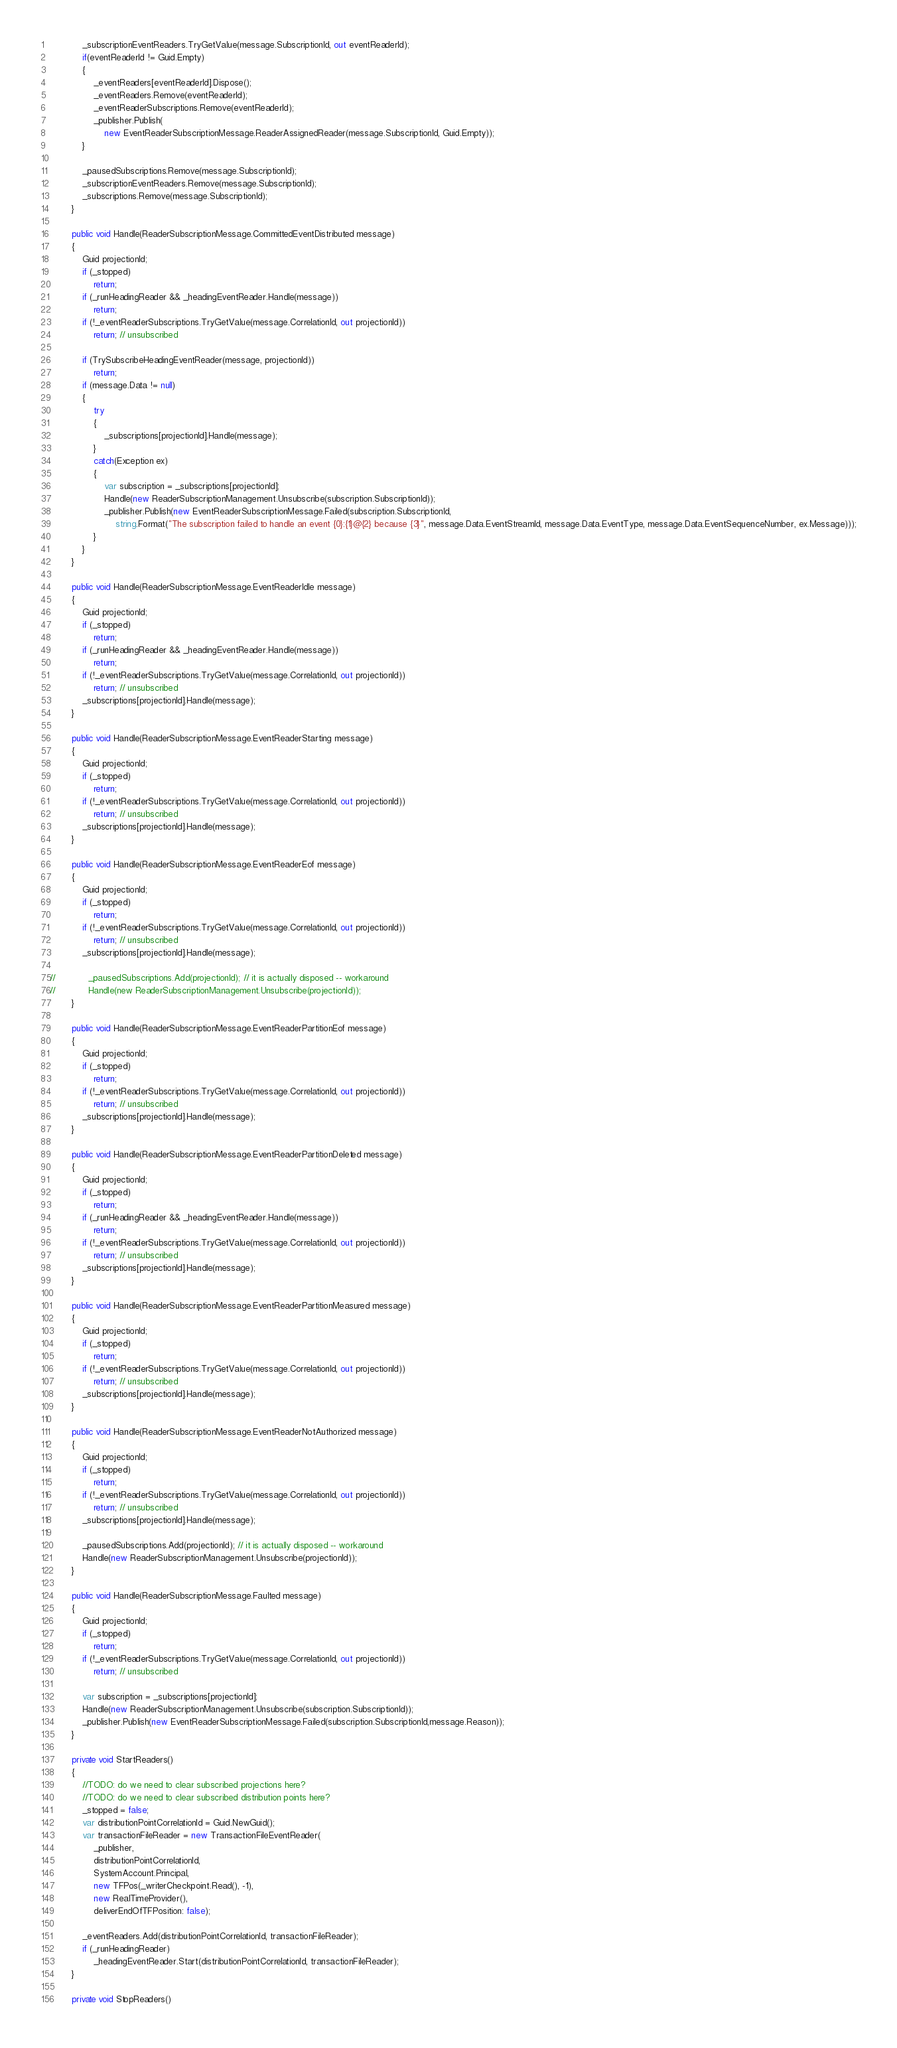Convert code to text. <code><loc_0><loc_0><loc_500><loc_500><_C#_>            _subscriptionEventReaders.TryGetValue(message.SubscriptionId, out eventReaderId);
            if(eventReaderId != Guid.Empty)
            {
                _eventReaders[eventReaderId].Dispose();
                _eventReaders.Remove(eventReaderId);
                _eventReaderSubscriptions.Remove(eventReaderId);
                _publisher.Publish(
                    new EventReaderSubscriptionMessage.ReaderAssignedReader(message.SubscriptionId, Guid.Empty));
            }

            _pausedSubscriptions.Remove(message.SubscriptionId);
            _subscriptionEventReaders.Remove(message.SubscriptionId);
            _subscriptions.Remove(message.SubscriptionId);
        }

        public void Handle(ReaderSubscriptionMessage.CommittedEventDistributed message)
        {
            Guid projectionId;
            if (_stopped)
                return;
            if (_runHeadingReader && _headingEventReader.Handle(message))
                return;
            if (!_eventReaderSubscriptions.TryGetValue(message.CorrelationId, out projectionId))
                return; // unsubscribed

            if (TrySubscribeHeadingEventReader(message, projectionId))
                return;
            if (message.Data != null)
            {
                try
                {
                    _subscriptions[projectionId].Handle(message);
                }
                catch(Exception ex)
                {
                    var subscription = _subscriptions[projectionId];
                    Handle(new ReaderSubscriptionManagement.Unsubscribe(subscription.SubscriptionId));
                    _publisher.Publish(new EventReaderSubscriptionMessage.Failed(subscription.SubscriptionId,
                        string.Format("The subscription failed to handle an event {0}:{1}@{2} because {3}", message.Data.EventStreamId, message.Data.EventType, message.Data.EventSequenceNumber, ex.Message)));
                }
            }
        }

        public void Handle(ReaderSubscriptionMessage.EventReaderIdle message)
        {
            Guid projectionId;
            if (_stopped)
                return;
            if (_runHeadingReader && _headingEventReader.Handle(message))
                return;
            if (!_eventReaderSubscriptions.TryGetValue(message.CorrelationId, out projectionId))
                return; // unsubscribed
            _subscriptions[projectionId].Handle(message);
        }

        public void Handle(ReaderSubscriptionMessage.EventReaderStarting message)
        {
            Guid projectionId;
            if (_stopped)
                return;
            if (!_eventReaderSubscriptions.TryGetValue(message.CorrelationId, out projectionId))
                return; // unsubscribed
            _subscriptions[projectionId].Handle(message);
        }

        public void Handle(ReaderSubscriptionMessage.EventReaderEof message)
        {
            Guid projectionId;
            if (_stopped)
                return;
            if (!_eventReaderSubscriptions.TryGetValue(message.CorrelationId, out projectionId))
                return; // unsubscribed
            _subscriptions[projectionId].Handle(message);

//            _pausedSubscriptions.Add(projectionId); // it is actually disposed -- workaround
//            Handle(new ReaderSubscriptionManagement.Unsubscribe(projectionId));
        }

        public void Handle(ReaderSubscriptionMessage.EventReaderPartitionEof message)
        {
            Guid projectionId;
            if (_stopped)
                return;
            if (!_eventReaderSubscriptions.TryGetValue(message.CorrelationId, out projectionId))
                return; // unsubscribed
            _subscriptions[projectionId].Handle(message);
        }

        public void Handle(ReaderSubscriptionMessage.EventReaderPartitionDeleted message)
        {
            Guid projectionId;
            if (_stopped)
                return;
            if (_runHeadingReader && _headingEventReader.Handle(message))
                return;
            if (!_eventReaderSubscriptions.TryGetValue(message.CorrelationId, out projectionId))
                return; // unsubscribed
            _subscriptions[projectionId].Handle(message);
        }

        public void Handle(ReaderSubscriptionMessage.EventReaderPartitionMeasured message)
        {
            Guid projectionId;
            if (_stopped)
                return;
            if (!_eventReaderSubscriptions.TryGetValue(message.CorrelationId, out projectionId))
                return; // unsubscribed
            _subscriptions[projectionId].Handle(message);
        }

        public void Handle(ReaderSubscriptionMessage.EventReaderNotAuthorized message)
        {
            Guid projectionId;
            if (_stopped)
                return;
            if (!_eventReaderSubscriptions.TryGetValue(message.CorrelationId, out projectionId))
                return; // unsubscribed
            _subscriptions[projectionId].Handle(message);

            _pausedSubscriptions.Add(projectionId); // it is actually disposed -- workaround
            Handle(new ReaderSubscriptionManagement.Unsubscribe(projectionId));
        }

        public void Handle(ReaderSubscriptionMessage.Faulted message)
        {
            Guid projectionId;
            if (_stopped)
                return;
            if (!_eventReaderSubscriptions.TryGetValue(message.CorrelationId, out projectionId))
                return; // unsubscribed

            var subscription = _subscriptions[projectionId];
            Handle(new ReaderSubscriptionManagement.Unsubscribe(subscription.SubscriptionId));
            _publisher.Publish(new EventReaderSubscriptionMessage.Failed(subscription.SubscriptionId,message.Reason));            
        }

        private void StartReaders()
        {
            //TODO: do we need to clear subscribed projections here?
            //TODO: do we need to clear subscribed distribution points here?
            _stopped = false;
            var distributionPointCorrelationId = Guid.NewGuid();
            var transactionFileReader = new TransactionFileEventReader(
                _publisher,
                distributionPointCorrelationId,
                SystemAccount.Principal,
                new TFPos(_writerCheckpoint.Read(), -1),
                new RealTimeProvider(),
                deliverEndOfTFPosition: false);

            _eventReaders.Add(distributionPointCorrelationId, transactionFileReader);
            if (_runHeadingReader)
                _headingEventReader.Start(distributionPointCorrelationId, transactionFileReader);
        }

        private void StopReaders()</code> 